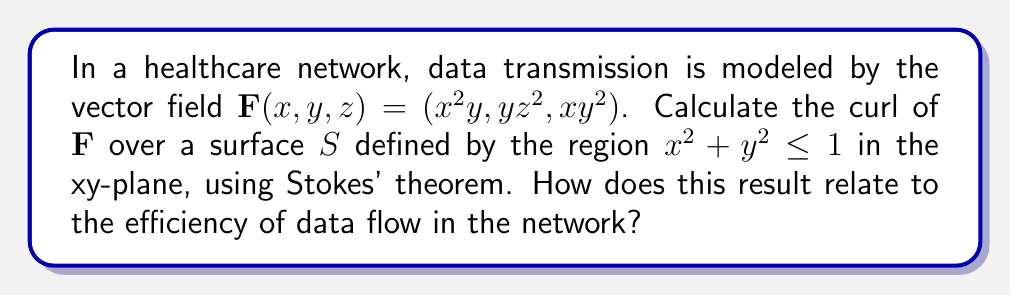Give your solution to this math problem. 1) First, we need to calculate the curl of $\mathbf{F}$:
   $$\text{curl }\mathbf{F} = \nabla \times \mathbf{F} = \left(\frac{\partial F_z}{\partial y} - \frac{\partial F_y}{\partial z}, \frac{\partial F_x}{\partial z} - \frac{\partial F_z}{\partial x}, \frac{\partial F_y}{\partial x} - \frac{\partial F_x}{\partial y}\right)$$
   $$= (2xy - 2yz, 0 - y^2, z^2 - 2xy)$$

2) Stokes' theorem states that:
   $$\iint_S (\nabla \times \mathbf{F}) \cdot d\mathbf{S} = \oint_C \mathbf{F} \cdot d\mathbf{r}$$
   where $C$ is the boundary of surface $S$.

3) The surface $S$ is a circular disk in the xy-plane, so $d\mathbf{S} = \hat{k}dxdy$. We only need to consider the z-component of curl $\mathbf{F}$:
   $$\iint_S (\nabla \times \mathbf{F}) \cdot d\mathbf{S} = \iint_S (z^2 - 2xy)dxdy$$

4) Convert to polar coordinates: $x = r\cos\theta, y = r\sin\theta, dxdy = rdrd\theta$
   $$\int_0^{2\pi} \int_0^1 (0 - 2r^2\cos\theta\sin\theta)rdrd\theta$$
   $$= -2\int_0^{2\pi} \int_0^1 r^3\cos\theta\sin\theta drd\theta$$

5) Integrate with respect to $r$:
   $$= -2\int_0^{2\pi} [\frac{r^4}{4}\cos\theta\sin\theta]_0^1 d\theta = -\frac{1}{2}\int_0^{2\pi} \cos\theta\sin\theta d\theta$$

6) Integrate with respect to $\theta$:
   $$= -\frac{1}{2}[\frac{-\cos^2\theta}{2}]_0^{2\pi} = 0$$

The result of 0 indicates that there is no net circulation of data in this healthcare network model. This suggests that the data flow is balanced and efficient, with no areas of data congestion or underutilization in the network.
Answer: 0 